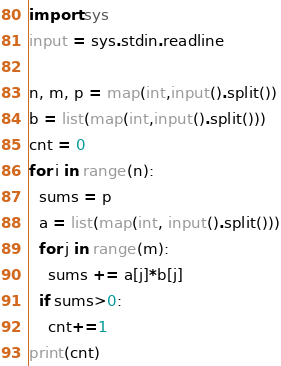<code> <loc_0><loc_0><loc_500><loc_500><_Python_>import sys
input = sys.stdin.readline

n, m, p = map(int,input().split())
b = list(map(int,input().split()))
cnt = 0
for i in range(n):
  sums = p
  a = list(map(int, input().split()))
  for j in range(m):
    sums += a[j]*b[j]
  if sums>0:
    cnt+=1
print(cnt)</code> 